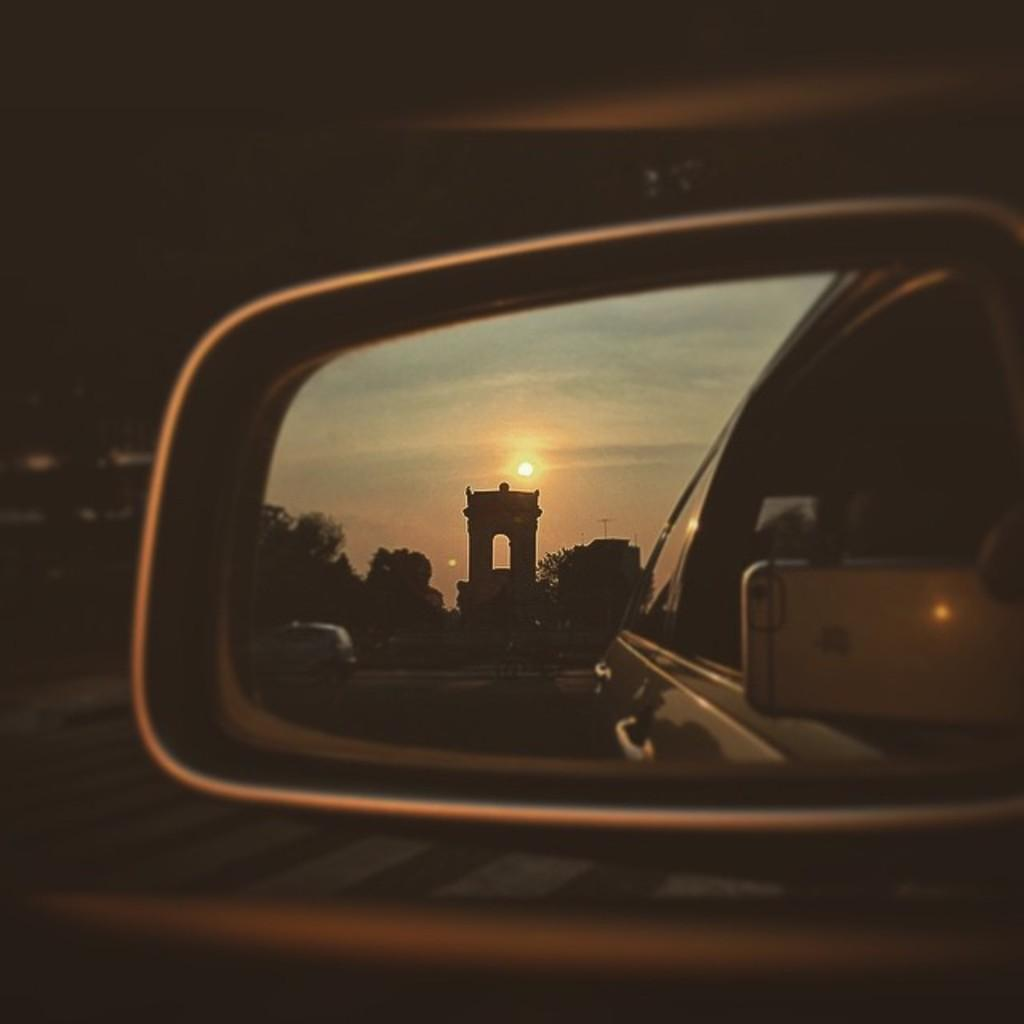What type of vehicle is shown in the image? The image features a mirror of a vehicle, but it does not show the entire vehicle. What type of trees can be seen in the image? There are larch trees and other trees visible in the image. What structures are present in the image? Poles are present in the image. What electronic device is visible in the image? A mobile phone is visible in the image. What type of surface is visible in the image? There is a road visible in the image. What is visible in the mirror of the vehicle? There is a vehicle visible in the mirror. What is visible in the background of the image? There is a road visible in the background of the image. What type of juice is being advertised in the image? There is no juice or advertisement present in the image. What type of soda is being consumed by the person in the image? There is no person or soda visible in the image. 